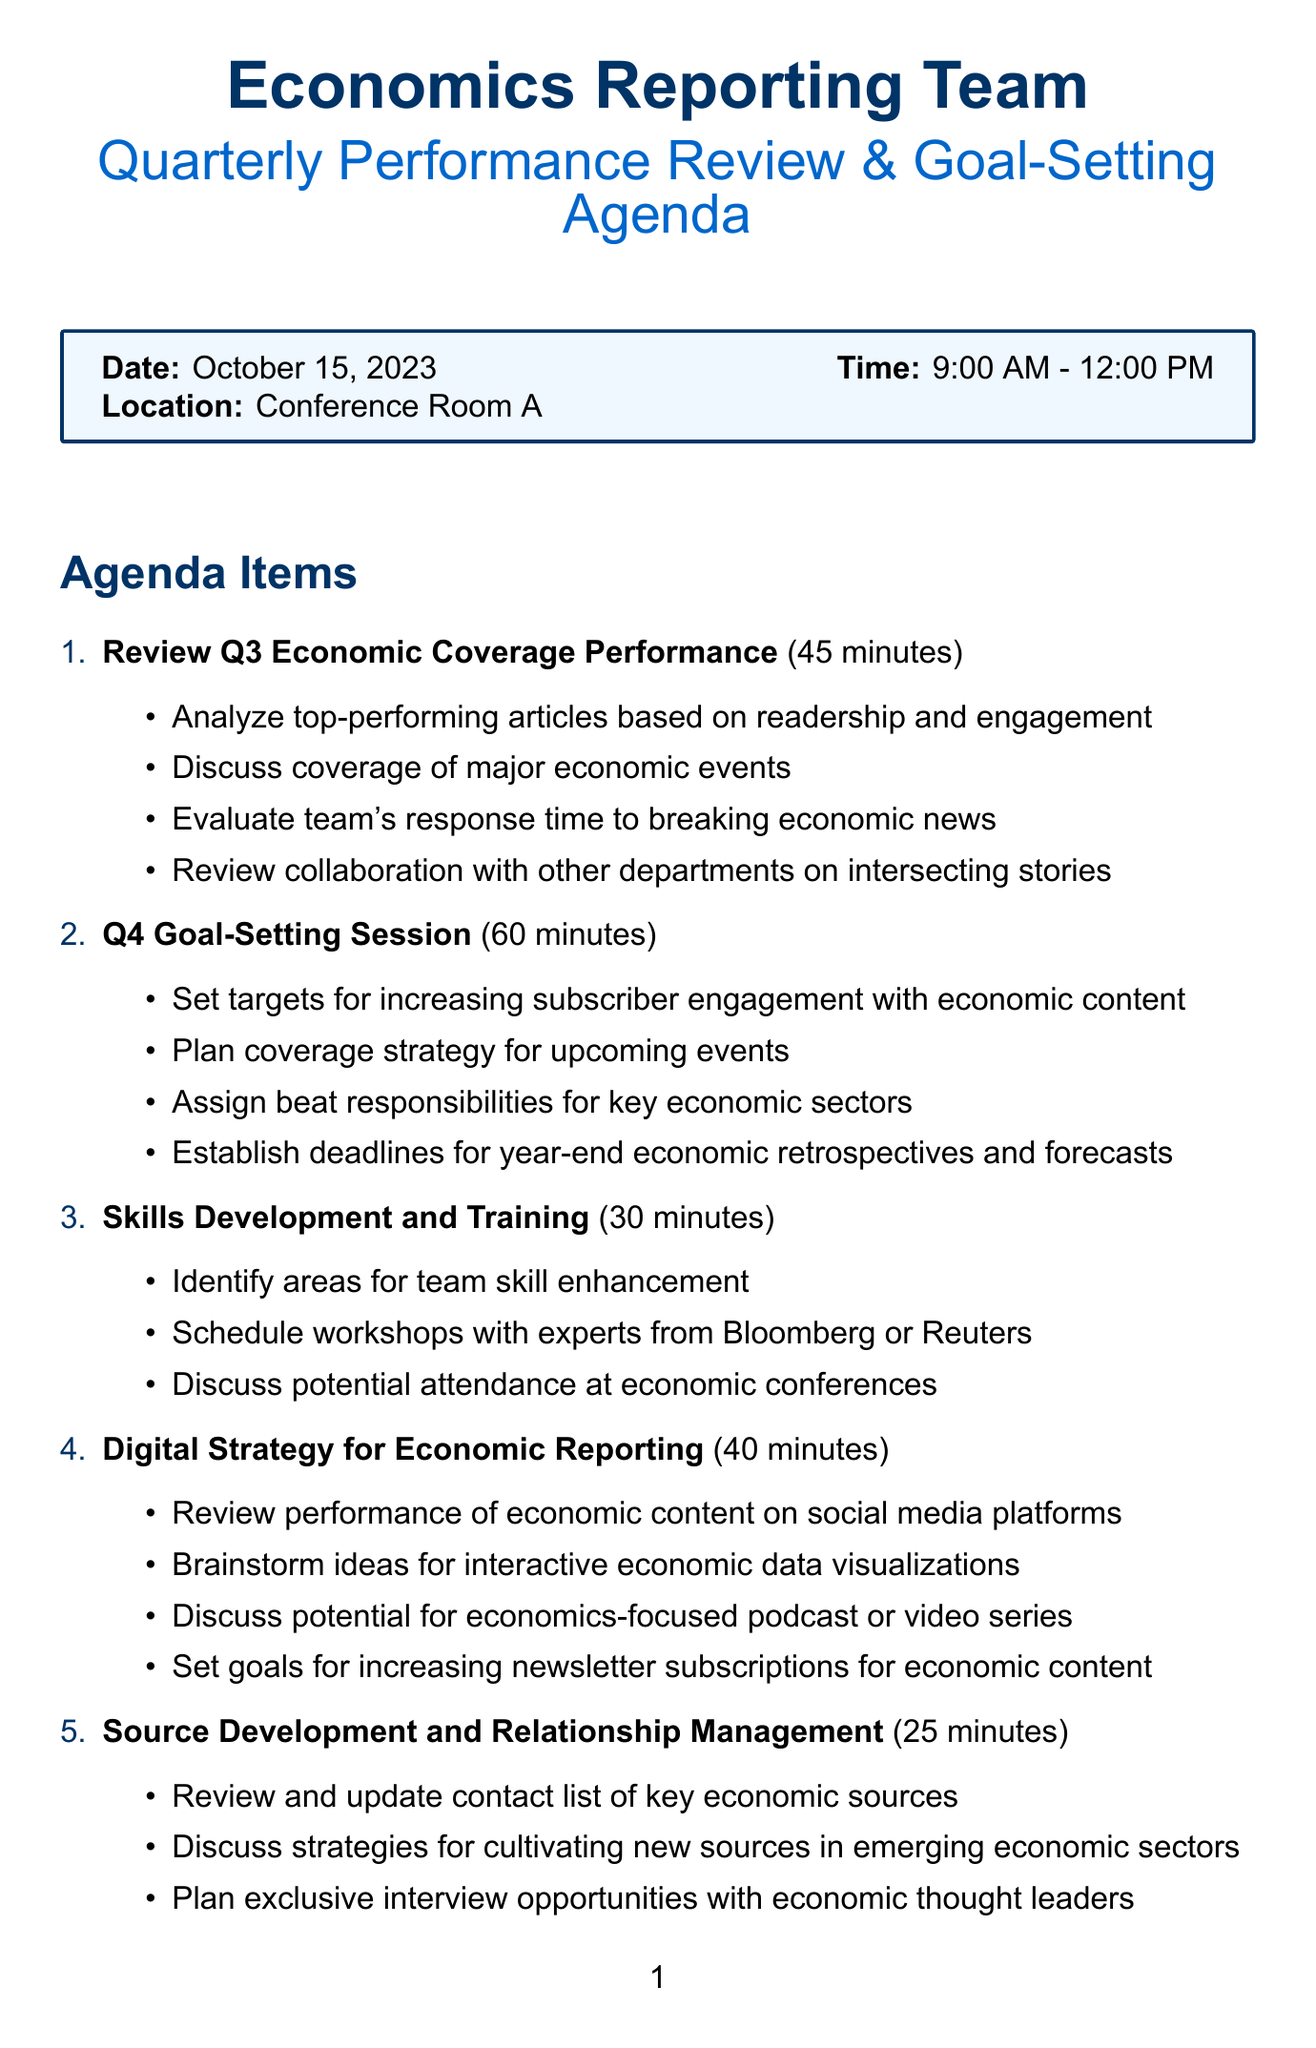What is the date of the meeting? The date of the meeting is stated in the logistics section of the document.
Answer: October 15, 2023 How long is the Q4 goal-setting session? The duration of the Q4 goal-setting session is provided in the agenda items section.
Answer: 60 minutes Who is the primary participant listed for the meeting? The participants section lists all attendees, with the Chief Economics Editor being the primary participant.
Answer: Chief Economics Editor What are the required materials for the meeting? The required materials are listed in a box within the document.
Answer: Q3 performance reports, Economic calendar for Q4, Team member portfolios, Digital analytics dashboard What is one goal for the Q4 goal-setting session? The document lists activities in this session, one of which specifies a clear goal regarding engagement.
Answer: Set targets for increasing subscriber engagement with economic content Which agenda item has the shortest duration? The durations for each agenda item are outlined, making it possible to identify the shortest.
Answer: Source Development and Relationship Management What is the focus of the Skills Development and Training session? The activities in this session highlight the key focus area for skill enhancement in the team.
Answer: Identify areas for team skill enhancement How many agenda items are there? The number of agenda items can be determined by counting them in the document.
Answer: Six 